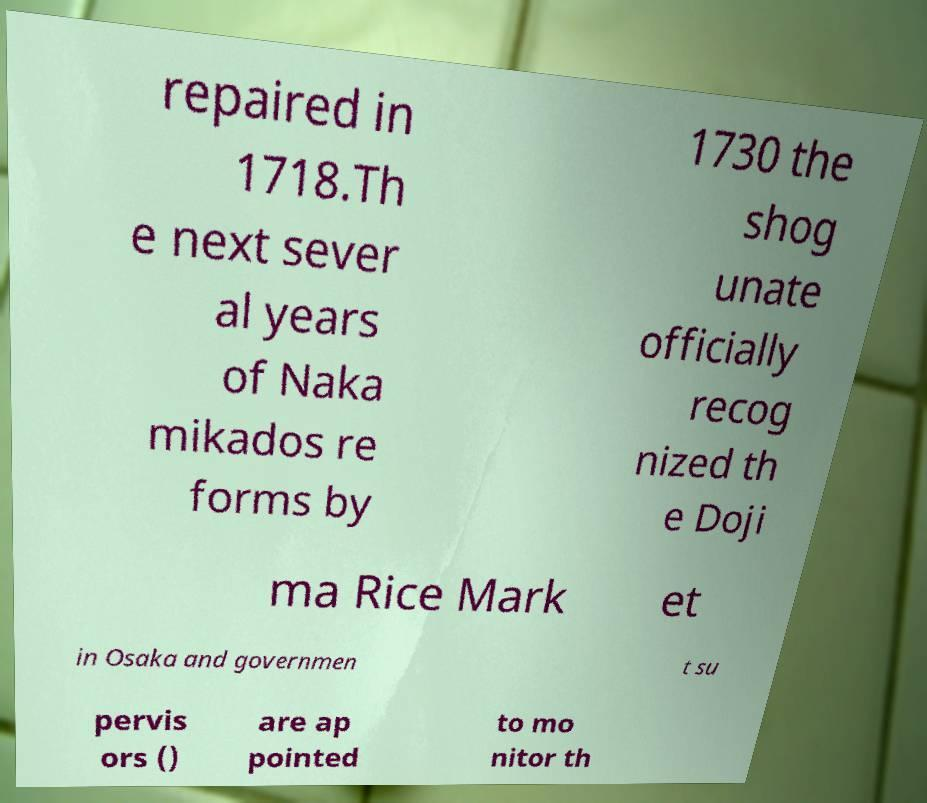There's text embedded in this image that I need extracted. Can you transcribe it verbatim? repaired in 1718.Th e next sever al years of Naka mikados re forms by 1730 the shog unate officially recog nized th e Doji ma Rice Mark et in Osaka and governmen t su pervis ors () are ap pointed to mo nitor th 